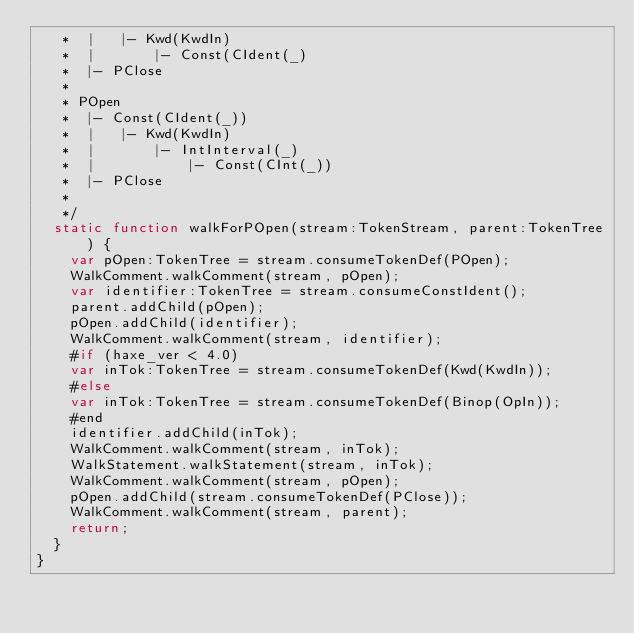<code> <loc_0><loc_0><loc_500><loc_500><_Haxe_>	 *  |   |- Kwd(KwdIn)
	 *  |       |- Const(CIdent(_)
	 *  |- PClose
	 *
	 * POpen
	 *  |- Const(CIdent(_))
	 *  |   |- Kwd(KwdIn)
	 *  |       |- IntInterval(_)
	 *  |           |- Const(CInt(_))
	 *  |- PClose
	 *
	 */
	static function walkForPOpen(stream:TokenStream, parent:TokenTree) {
		var pOpen:TokenTree = stream.consumeTokenDef(POpen);
		WalkComment.walkComment(stream, pOpen);
		var identifier:TokenTree = stream.consumeConstIdent();
		parent.addChild(pOpen);
		pOpen.addChild(identifier);
		WalkComment.walkComment(stream, identifier);
		#if (haxe_ver < 4.0)
		var inTok:TokenTree = stream.consumeTokenDef(Kwd(KwdIn));
		#else
		var inTok:TokenTree = stream.consumeTokenDef(Binop(OpIn));
		#end
		identifier.addChild(inTok);
		WalkComment.walkComment(stream, inTok);
		WalkStatement.walkStatement(stream, inTok);
		WalkComment.walkComment(stream, pOpen);
		pOpen.addChild(stream.consumeTokenDef(PClose));
		WalkComment.walkComment(stream, parent);
		return;
	}
}</code> 